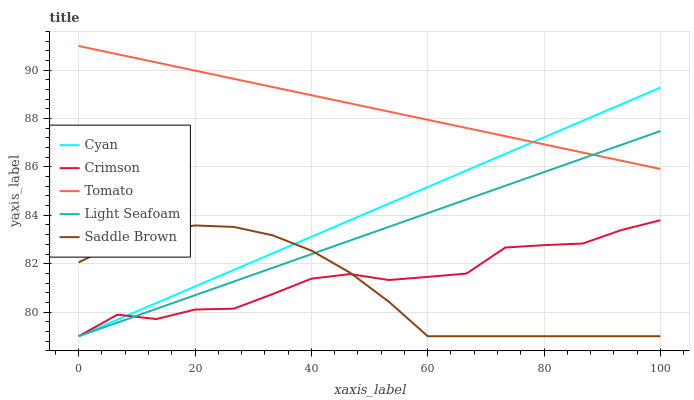Does Saddle Brown have the minimum area under the curve?
Answer yes or no. Yes. Does Tomato have the maximum area under the curve?
Answer yes or no. Yes. Does Cyan have the minimum area under the curve?
Answer yes or no. No. Does Cyan have the maximum area under the curve?
Answer yes or no. No. Is Light Seafoam the smoothest?
Answer yes or no. Yes. Is Crimson the roughest?
Answer yes or no. Yes. Is Cyan the smoothest?
Answer yes or no. No. Is Cyan the roughest?
Answer yes or no. No. Does Crimson have the lowest value?
Answer yes or no. Yes. Does Tomato have the lowest value?
Answer yes or no. No. Does Tomato have the highest value?
Answer yes or no. Yes. Does Cyan have the highest value?
Answer yes or no. No. Is Crimson less than Tomato?
Answer yes or no. Yes. Is Tomato greater than Saddle Brown?
Answer yes or no. Yes. Does Cyan intersect Light Seafoam?
Answer yes or no. Yes. Is Cyan less than Light Seafoam?
Answer yes or no. No. Is Cyan greater than Light Seafoam?
Answer yes or no. No. Does Crimson intersect Tomato?
Answer yes or no. No. 